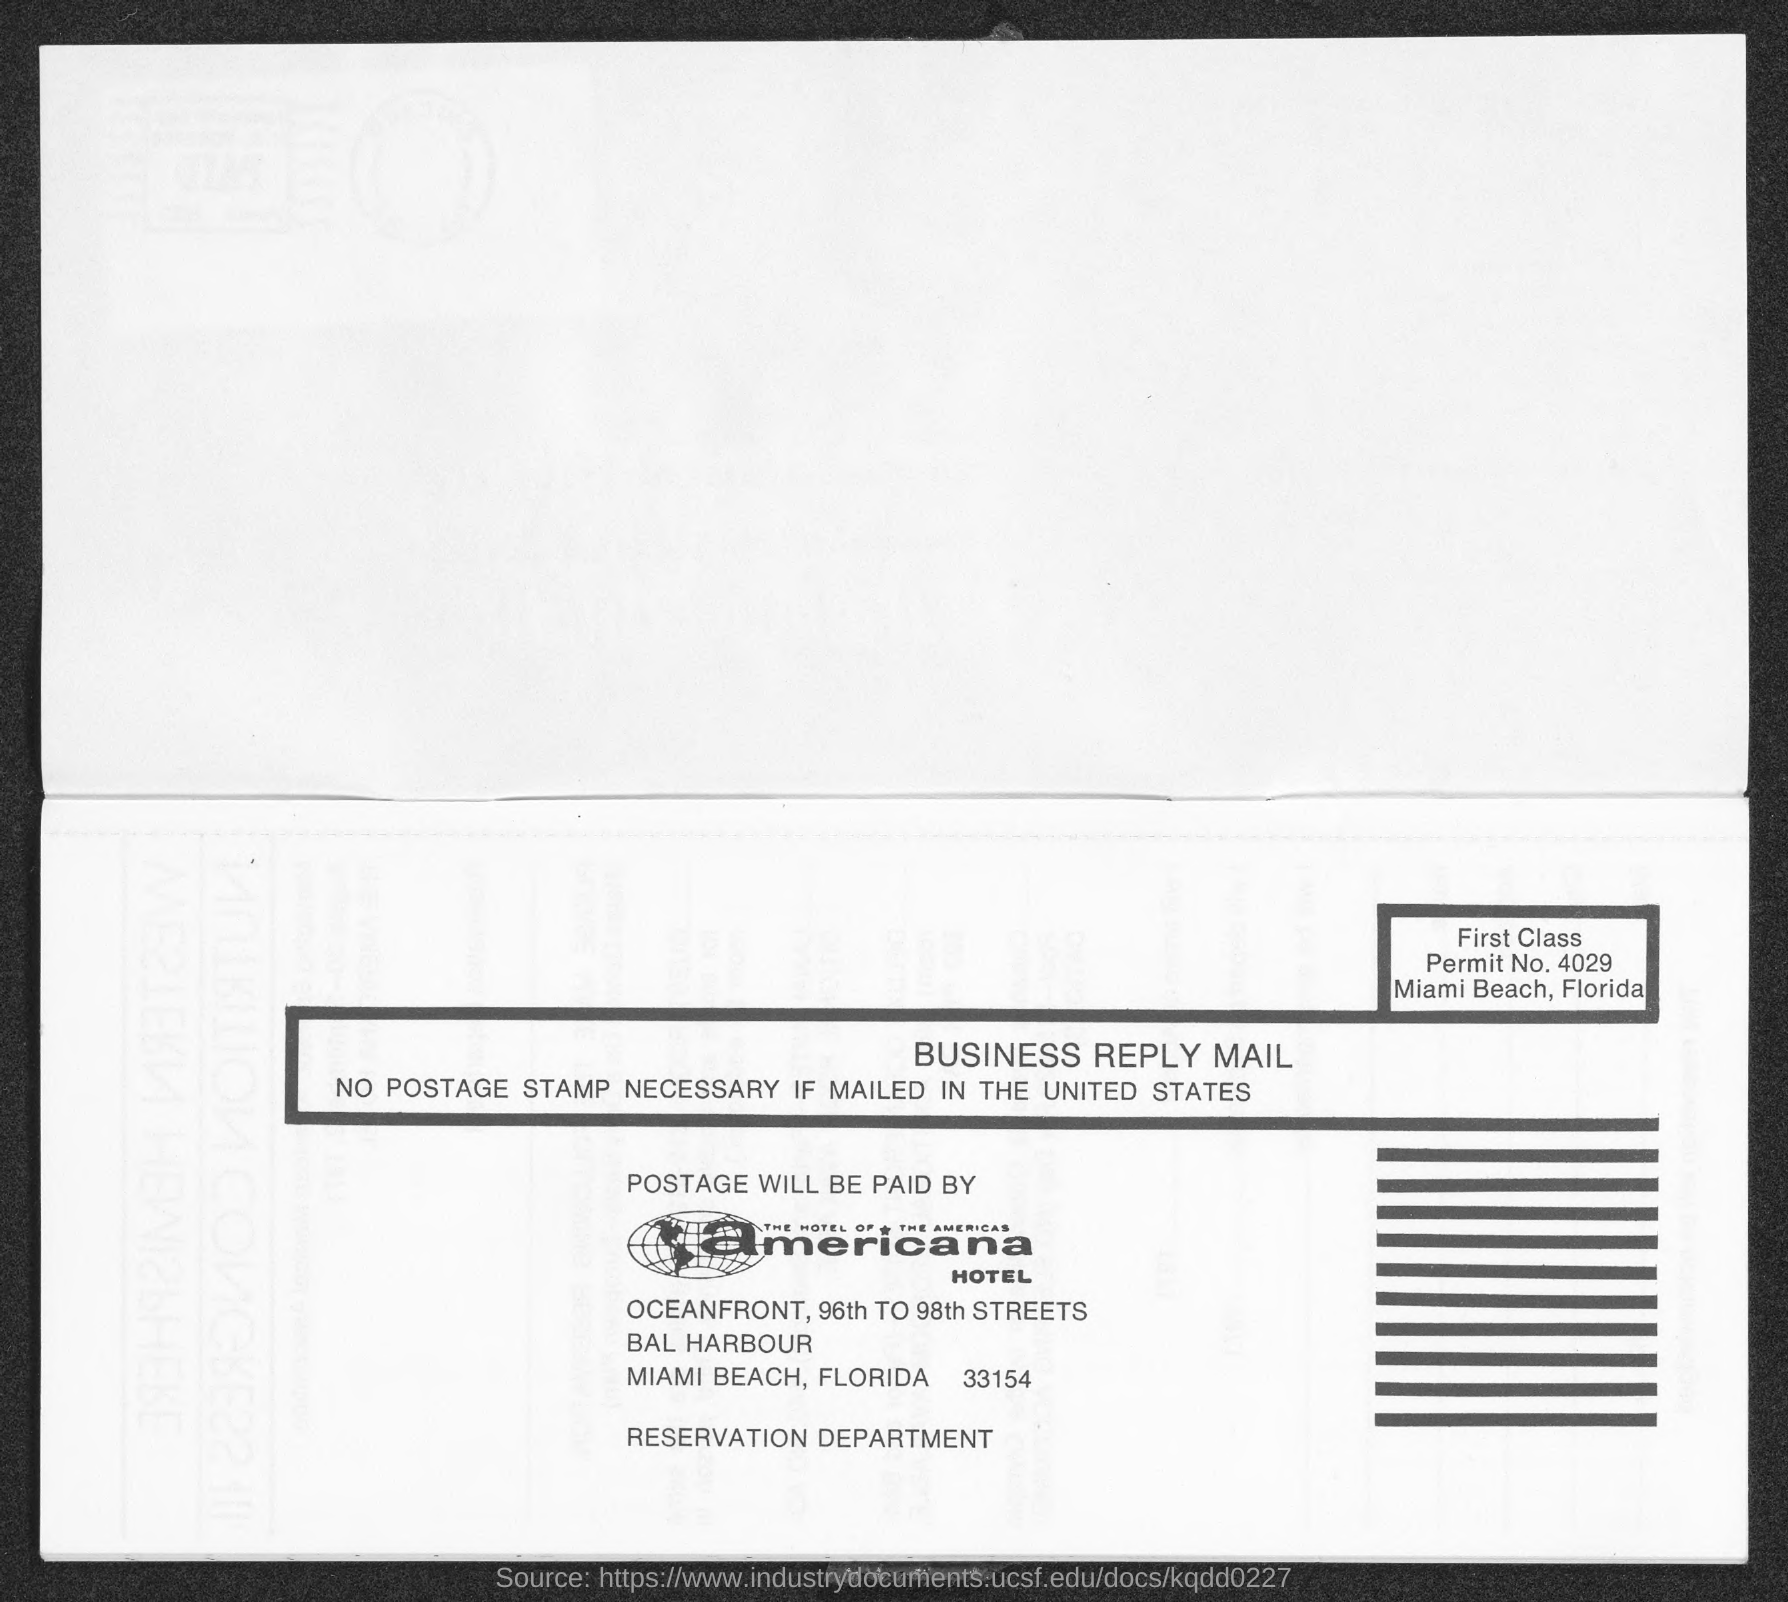Outline some significant characteristics in this image. The permit number is 4029. The Americana hotel is located in Florida. 